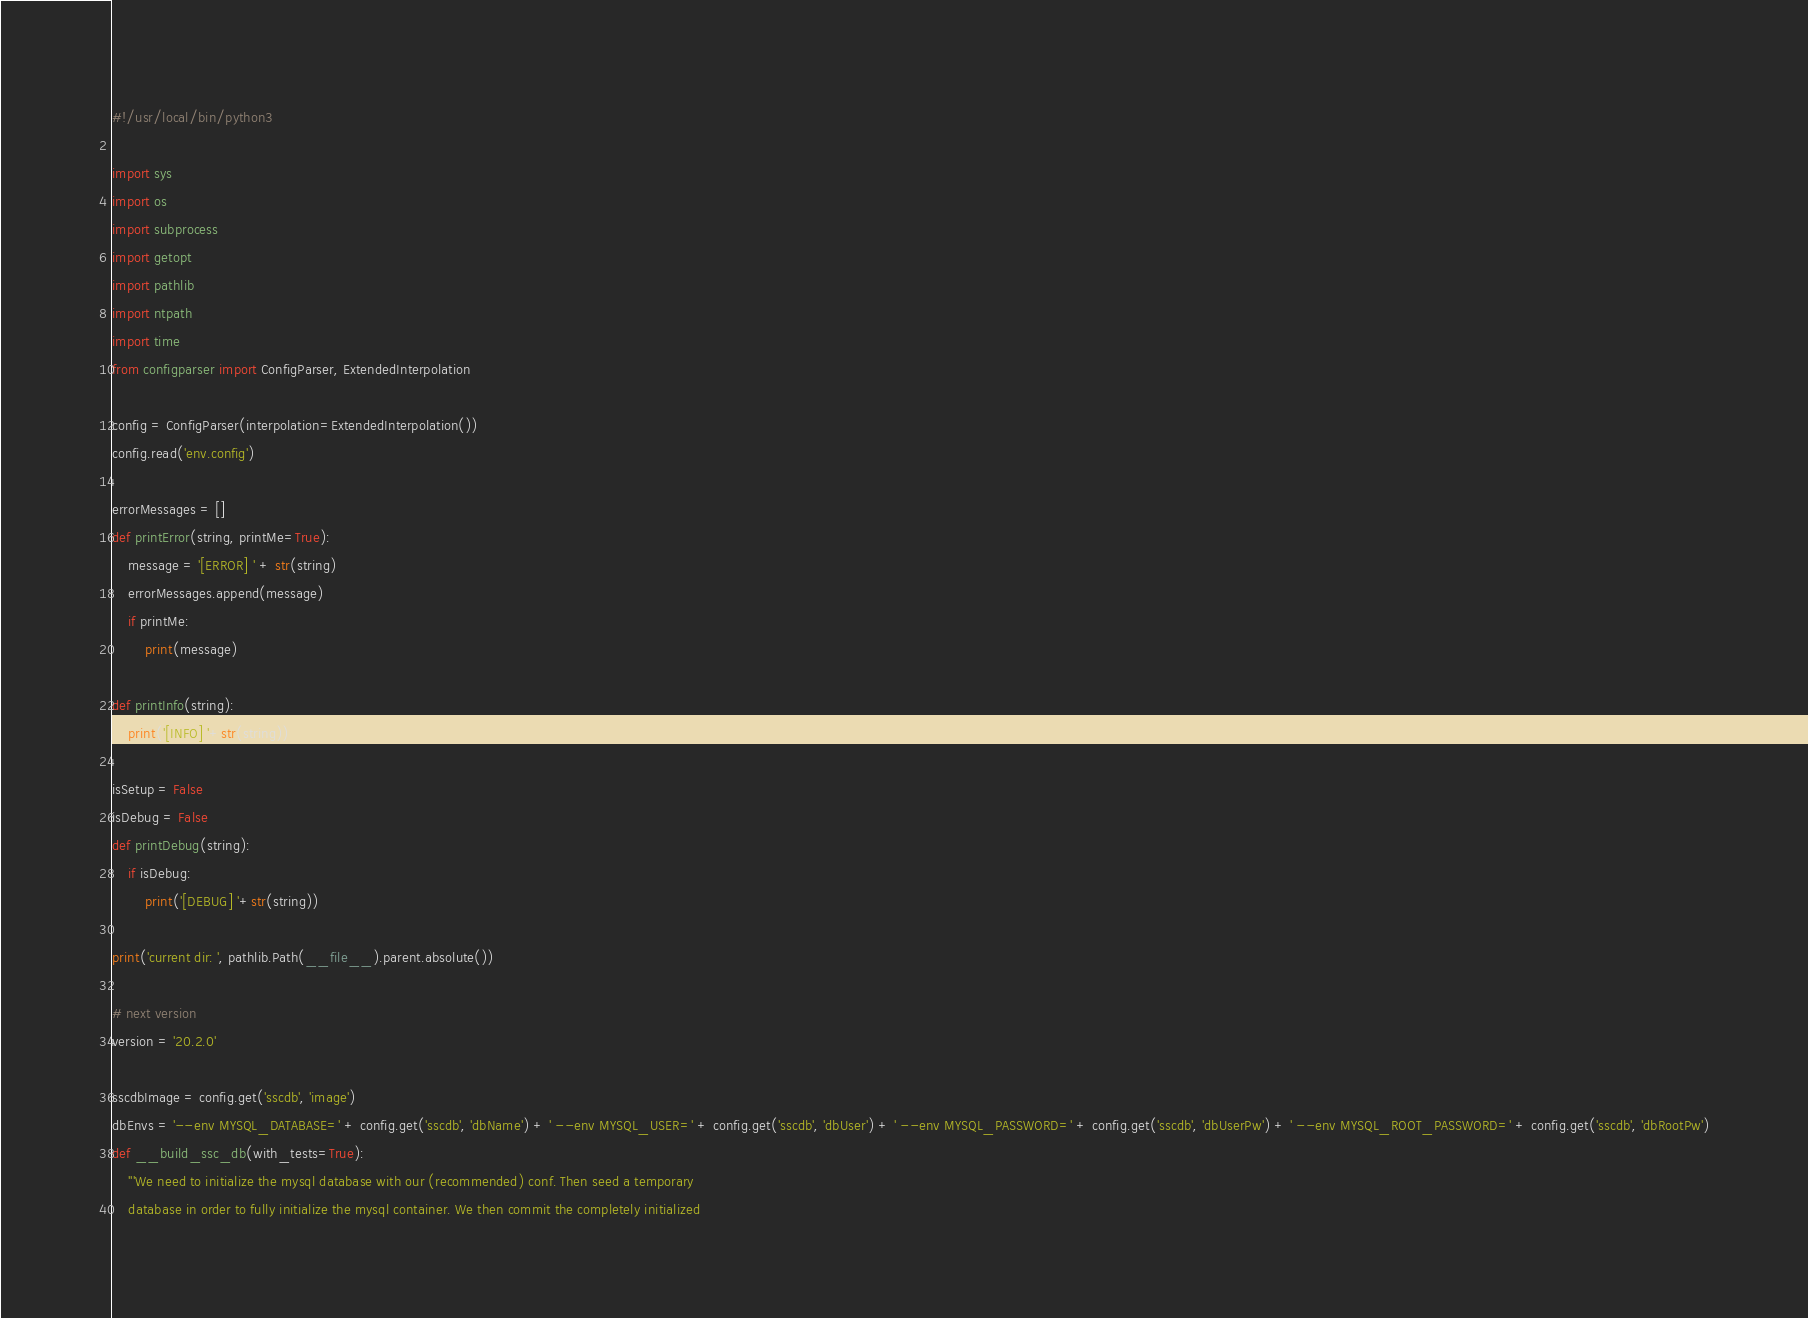<code> <loc_0><loc_0><loc_500><loc_500><_Python_>#!/usr/local/bin/python3

import sys
import os
import subprocess
import getopt
import pathlib
import ntpath
import time
from configparser import ConfigParser, ExtendedInterpolation

config = ConfigParser(interpolation=ExtendedInterpolation())
config.read('env.config')

errorMessages = []
def printError(string, printMe=True):
	message = '[ERROR] ' + str(string)
	errorMessages.append(message)
	if printMe:
		print(message)
	
def printInfo(string):
	print('[INFO] '+str(string))

isSetup = False
isDebug = False
def printDebug(string):
	if isDebug:
		print('[DEBUG] '+str(string))

print('current dir: ', pathlib.Path(__file__).parent.absolute())

# next version
version = '20.2.0'
	
sscdbImage = config.get('sscdb', 'image')
dbEnvs = '--env MYSQL_DATABASE=' + config.get('sscdb', 'dbName') + ' --env MYSQL_USER=' + config.get('sscdb', 'dbUser') + ' --env MYSQL_PASSWORD=' + config.get('sscdb', 'dbUserPw') + ' --env MYSQL_ROOT_PASSWORD=' + config.get('sscdb', 'dbRootPw')
def __build_ssc_db(with_tests=True):
	'''We need to initialize the mysql database with our (recommended) conf. Then seed a temporary
	database in order to fully initialize the mysql container. We then commit the completely initialized </code> 